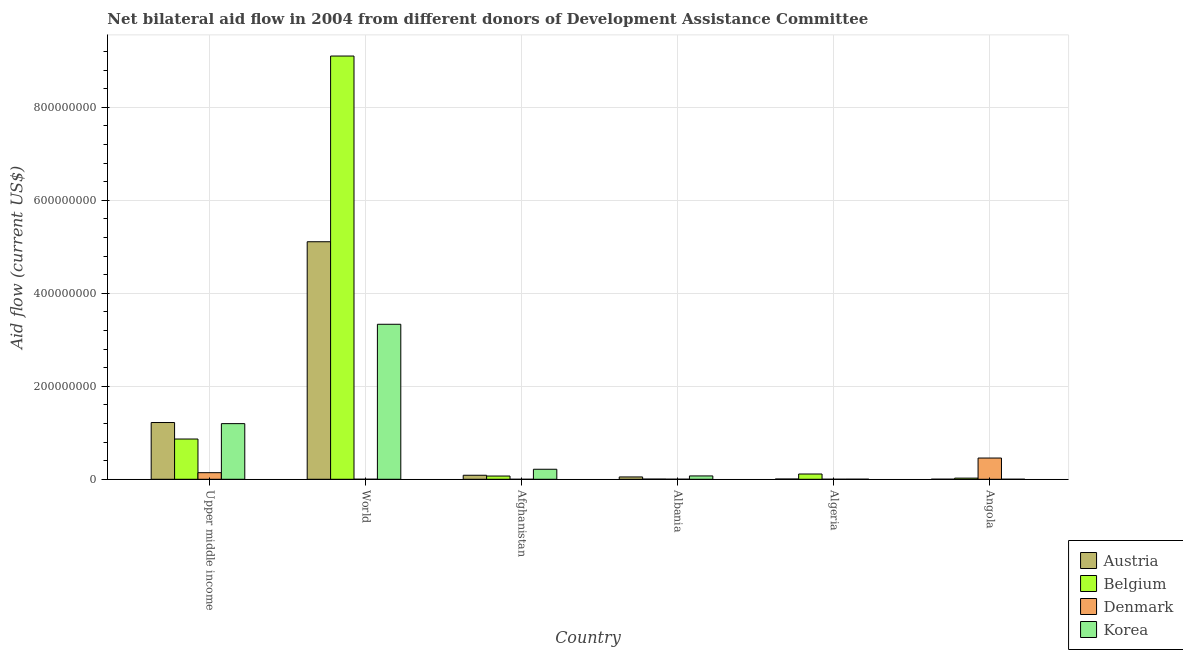Are the number of bars per tick equal to the number of legend labels?
Ensure brevity in your answer.  No. Are the number of bars on each tick of the X-axis equal?
Offer a very short reply. No. How many bars are there on the 5th tick from the left?
Your response must be concise. 4. How many bars are there on the 1st tick from the right?
Your answer should be compact. 4. What is the label of the 1st group of bars from the left?
Provide a short and direct response. Upper middle income. What is the amount of aid given by austria in Afghanistan?
Offer a terse response. 8.65e+06. Across all countries, what is the maximum amount of aid given by belgium?
Your response must be concise. 9.10e+08. Across all countries, what is the minimum amount of aid given by austria?
Ensure brevity in your answer.  1.50e+05. What is the total amount of aid given by korea in the graph?
Make the answer very short. 4.82e+08. What is the difference between the amount of aid given by denmark in Angola and that in World?
Your answer should be very brief. 4.56e+07. What is the difference between the amount of aid given by austria in Angola and the amount of aid given by denmark in Upper middle income?
Offer a terse response. -1.40e+07. What is the average amount of aid given by denmark per country?
Give a very brief answer. 1.00e+07. What is the difference between the amount of aid given by austria and amount of aid given by belgium in Upper middle income?
Your answer should be very brief. 3.55e+07. In how many countries, is the amount of aid given by belgium greater than 640000000 US$?
Provide a succinct answer. 1. What is the ratio of the amount of aid given by belgium in Albania to that in Upper middle income?
Give a very brief answer. 0. What is the difference between the highest and the second highest amount of aid given by denmark?
Your answer should be compact. 3.15e+07. What is the difference between the highest and the lowest amount of aid given by denmark?
Ensure brevity in your answer.  4.57e+07. Is the sum of the amount of aid given by korea in Algeria and Upper middle income greater than the maximum amount of aid given by denmark across all countries?
Provide a short and direct response. Yes. Is it the case that in every country, the sum of the amount of aid given by austria and amount of aid given by belgium is greater than the amount of aid given by denmark?
Your answer should be very brief. No. What is the difference between two consecutive major ticks on the Y-axis?
Offer a terse response. 2.00e+08. Are the values on the major ticks of Y-axis written in scientific E-notation?
Provide a succinct answer. No. Does the graph contain any zero values?
Ensure brevity in your answer.  Yes. How many legend labels are there?
Give a very brief answer. 4. How are the legend labels stacked?
Your answer should be very brief. Vertical. What is the title of the graph?
Make the answer very short. Net bilateral aid flow in 2004 from different donors of Development Assistance Committee. What is the label or title of the X-axis?
Ensure brevity in your answer.  Country. What is the label or title of the Y-axis?
Offer a terse response. Aid flow (current US$). What is the Aid flow (current US$) of Austria in Upper middle income?
Make the answer very short. 1.22e+08. What is the Aid flow (current US$) of Belgium in Upper middle income?
Provide a short and direct response. 8.66e+07. What is the Aid flow (current US$) in Denmark in Upper middle income?
Provide a succinct answer. 1.42e+07. What is the Aid flow (current US$) of Korea in Upper middle income?
Provide a succinct answer. 1.20e+08. What is the Aid flow (current US$) in Austria in World?
Provide a short and direct response. 5.11e+08. What is the Aid flow (current US$) of Belgium in World?
Ensure brevity in your answer.  9.10e+08. What is the Aid flow (current US$) of Denmark in World?
Keep it short and to the point. 3.00e+04. What is the Aid flow (current US$) of Korea in World?
Make the answer very short. 3.33e+08. What is the Aid flow (current US$) in Austria in Afghanistan?
Make the answer very short. 8.65e+06. What is the Aid flow (current US$) in Belgium in Afghanistan?
Make the answer very short. 6.96e+06. What is the Aid flow (current US$) of Denmark in Afghanistan?
Give a very brief answer. 0. What is the Aid flow (current US$) in Korea in Afghanistan?
Your response must be concise. 2.15e+07. What is the Aid flow (current US$) of Austria in Albania?
Make the answer very short. 5.01e+06. What is the Aid flow (current US$) of Denmark in Albania?
Ensure brevity in your answer.  1.20e+05. What is the Aid flow (current US$) of Korea in Albania?
Keep it short and to the point. 7.20e+06. What is the Aid flow (current US$) of Austria in Algeria?
Keep it short and to the point. 5.40e+05. What is the Aid flow (current US$) in Belgium in Algeria?
Offer a terse response. 1.13e+07. What is the Aid flow (current US$) of Denmark in Algeria?
Your answer should be very brief. 6.00e+04. What is the Aid flow (current US$) in Korea in Algeria?
Make the answer very short. 1.40e+05. What is the Aid flow (current US$) of Belgium in Angola?
Give a very brief answer. 2.45e+06. What is the Aid flow (current US$) in Denmark in Angola?
Offer a terse response. 4.57e+07. Across all countries, what is the maximum Aid flow (current US$) in Austria?
Make the answer very short. 5.11e+08. Across all countries, what is the maximum Aid flow (current US$) of Belgium?
Ensure brevity in your answer.  9.10e+08. Across all countries, what is the maximum Aid flow (current US$) in Denmark?
Keep it short and to the point. 4.57e+07. Across all countries, what is the maximum Aid flow (current US$) of Korea?
Give a very brief answer. 3.33e+08. What is the total Aid flow (current US$) in Austria in the graph?
Offer a very short reply. 6.47e+08. What is the total Aid flow (current US$) in Belgium in the graph?
Your answer should be very brief. 1.02e+09. What is the total Aid flow (current US$) of Denmark in the graph?
Make the answer very short. 6.01e+07. What is the total Aid flow (current US$) in Korea in the graph?
Offer a very short reply. 4.82e+08. What is the difference between the Aid flow (current US$) in Austria in Upper middle income and that in World?
Give a very brief answer. -3.89e+08. What is the difference between the Aid flow (current US$) in Belgium in Upper middle income and that in World?
Give a very brief answer. -8.24e+08. What is the difference between the Aid flow (current US$) of Denmark in Upper middle income and that in World?
Keep it short and to the point. 1.42e+07. What is the difference between the Aid flow (current US$) of Korea in Upper middle income and that in World?
Your answer should be very brief. -2.14e+08. What is the difference between the Aid flow (current US$) of Austria in Upper middle income and that in Afghanistan?
Offer a terse response. 1.13e+08. What is the difference between the Aid flow (current US$) of Belgium in Upper middle income and that in Afghanistan?
Provide a succinct answer. 7.96e+07. What is the difference between the Aid flow (current US$) in Korea in Upper middle income and that in Afghanistan?
Your answer should be very brief. 9.81e+07. What is the difference between the Aid flow (current US$) of Austria in Upper middle income and that in Albania?
Offer a very short reply. 1.17e+08. What is the difference between the Aid flow (current US$) in Belgium in Upper middle income and that in Albania?
Provide a short and direct response. 8.62e+07. What is the difference between the Aid flow (current US$) of Denmark in Upper middle income and that in Albania?
Give a very brief answer. 1.41e+07. What is the difference between the Aid flow (current US$) of Korea in Upper middle income and that in Albania?
Your answer should be very brief. 1.12e+08. What is the difference between the Aid flow (current US$) in Austria in Upper middle income and that in Algeria?
Your answer should be compact. 1.22e+08. What is the difference between the Aid flow (current US$) in Belgium in Upper middle income and that in Algeria?
Make the answer very short. 7.53e+07. What is the difference between the Aid flow (current US$) in Denmark in Upper middle income and that in Algeria?
Your answer should be compact. 1.41e+07. What is the difference between the Aid flow (current US$) in Korea in Upper middle income and that in Algeria?
Keep it short and to the point. 1.20e+08. What is the difference between the Aid flow (current US$) in Austria in Upper middle income and that in Angola?
Provide a succinct answer. 1.22e+08. What is the difference between the Aid flow (current US$) of Belgium in Upper middle income and that in Angola?
Offer a terse response. 8.41e+07. What is the difference between the Aid flow (current US$) in Denmark in Upper middle income and that in Angola?
Offer a very short reply. -3.15e+07. What is the difference between the Aid flow (current US$) of Korea in Upper middle income and that in Angola?
Keep it short and to the point. 1.20e+08. What is the difference between the Aid flow (current US$) in Austria in World and that in Afghanistan?
Make the answer very short. 5.02e+08. What is the difference between the Aid flow (current US$) of Belgium in World and that in Afghanistan?
Ensure brevity in your answer.  9.03e+08. What is the difference between the Aid flow (current US$) of Korea in World and that in Afghanistan?
Keep it short and to the point. 3.12e+08. What is the difference between the Aid flow (current US$) of Austria in World and that in Albania?
Give a very brief answer. 5.06e+08. What is the difference between the Aid flow (current US$) in Belgium in World and that in Albania?
Offer a terse response. 9.10e+08. What is the difference between the Aid flow (current US$) in Korea in World and that in Albania?
Ensure brevity in your answer.  3.26e+08. What is the difference between the Aid flow (current US$) in Austria in World and that in Algeria?
Make the answer very short. 5.10e+08. What is the difference between the Aid flow (current US$) of Belgium in World and that in Algeria?
Provide a succinct answer. 8.99e+08. What is the difference between the Aid flow (current US$) in Denmark in World and that in Algeria?
Offer a very short reply. -3.00e+04. What is the difference between the Aid flow (current US$) in Korea in World and that in Algeria?
Your response must be concise. 3.33e+08. What is the difference between the Aid flow (current US$) of Austria in World and that in Angola?
Make the answer very short. 5.11e+08. What is the difference between the Aid flow (current US$) in Belgium in World and that in Angola?
Give a very brief answer. 9.08e+08. What is the difference between the Aid flow (current US$) in Denmark in World and that in Angola?
Make the answer very short. -4.56e+07. What is the difference between the Aid flow (current US$) in Korea in World and that in Angola?
Your answer should be compact. 3.33e+08. What is the difference between the Aid flow (current US$) of Austria in Afghanistan and that in Albania?
Offer a very short reply. 3.64e+06. What is the difference between the Aid flow (current US$) in Belgium in Afghanistan and that in Albania?
Ensure brevity in your answer.  6.59e+06. What is the difference between the Aid flow (current US$) in Korea in Afghanistan and that in Albania?
Your answer should be compact. 1.43e+07. What is the difference between the Aid flow (current US$) of Austria in Afghanistan and that in Algeria?
Ensure brevity in your answer.  8.11e+06. What is the difference between the Aid flow (current US$) of Belgium in Afghanistan and that in Algeria?
Provide a short and direct response. -4.36e+06. What is the difference between the Aid flow (current US$) of Korea in Afghanistan and that in Algeria?
Your answer should be compact. 2.14e+07. What is the difference between the Aid flow (current US$) in Austria in Afghanistan and that in Angola?
Make the answer very short. 8.50e+06. What is the difference between the Aid flow (current US$) of Belgium in Afghanistan and that in Angola?
Your answer should be compact. 4.51e+06. What is the difference between the Aid flow (current US$) of Korea in Afghanistan and that in Angola?
Provide a succinct answer. 2.15e+07. What is the difference between the Aid flow (current US$) of Austria in Albania and that in Algeria?
Make the answer very short. 4.47e+06. What is the difference between the Aid flow (current US$) of Belgium in Albania and that in Algeria?
Provide a succinct answer. -1.10e+07. What is the difference between the Aid flow (current US$) of Korea in Albania and that in Algeria?
Provide a short and direct response. 7.06e+06. What is the difference between the Aid flow (current US$) of Austria in Albania and that in Angola?
Give a very brief answer. 4.86e+06. What is the difference between the Aid flow (current US$) of Belgium in Albania and that in Angola?
Offer a terse response. -2.08e+06. What is the difference between the Aid flow (current US$) in Denmark in Albania and that in Angola?
Your response must be concise. -4.56e+07. What is the difference between the Aid flow (current US$) in Korea in Albania and that in Angola?
Provide a short and direct response. 7.16e+06. What is the difference between the Aid flow (current US$) of Belgium in Algeria and that in Angola?
Offer a terse response. 8.87e+06. What is the difference between the Aid flow (current US$) of Denmark in Algeria and that in Angola?
Make the answer very short. -4.56e+07. What is the difference between the Aid flow (current US$) of Korea in Algeria and that in Angola?
Give a very brief answer. 1.00e+05. What is the difference between the Aid flow (current US$) of Austria in Upper middle income and the Aid flow (current US$) of Belgium in World?
Provide a succinct answer. -7.88e+08. What is the difference between the Aid flow (current US$) in Austria in Upper middle income and the Aid flow (current US$) in Denmark in World?
Offer a terse response. 1.22e+08. What is the difference between the Aid flow (current US$) in Austria in Upper middle income and the Aid flow (current US$) in Korea in World?
Provide a short and direct response. -2.11e+08. What is the difference between the Aid flow (current US$) of Belgium in Upper middle income and the Aid flow (current US$) of Denmark in World?
Offer a very short reply. 8.66e+07. What is the difference between the Aid flow (current US$) in Belgium in Upper middle income and the Aid flow (current US$) in Korea in World?
Offer a very short reply. -2.47e+08. What is the difference between the Aid flow (current US$) in Denmark in Upper middle income and the Aid flow (current US$) in Korea in World?
Offer a very short reply. -3.19e+08. What is the difference between the Aid flow (current US$) of Austria in Upper middle income and the Aid flow (current US$) of Belgium in Afghanistan?
Your response must be concise. 1.15e+08. What is the difference between the Aid flow (current US$) of Austria in Upper middle income and the Aid flow (current US$) of Korea in Afghanistan?
Ensure brevity in your answer.  1.01e+08. What is the difference between the Aid flow (current US$) of Belgium in Upper middle income and the Aid flow (current US$) of Korea in Afghanistan?
Make the answer very short. 6.50e+07. What is the difference between the Aid flow (current US$) in Denmark in Upper middle income and the Aid flow (current US$) in Korea in Afghanistan?
Give a very brief answer. -7.36e+06. What is the difference between the Aid flow (current US$) of Austria in Upper middle income and the Aid flow (current US$) of Belgium in Albania?
Your response must be concise. 1.22e+08. What is the difference between the Aid flow (current US$) in Austria in Upper middle income and the Aid flow (current US$) in Denmark in Albania?
Offer a very short reply. 1.22e+08. What is the difference between the Aid flow (current US$) in Austria in Upper middle income and the Aid flow (current US$) in Korea in Albania?
Provide a short and direct response. 1.15e+08. What is the difference between the Aid flow (current US$) in Belgium in Upper middle income and the Aid flow (current US$) in Denmark in Albania?
Your answer should be very brief. 8.65e+07. What is the difference between the Aid flow (current US$) of Belgium in Upper middle income and the Aid flow (current US$) of Korea in Albania?
Your response must be concise. 7.94e+07. What is the difference between the Aid flow (current US$) of Denmark in Upper middle income and the Aid flow (current US$) of Korea in Albania?
Provide a short and direct response. 6.98e+06. What is the difference between the Aid flow (current US$) in Austria in Upper middle income and the Aid flow (current US$) in Belgium in Algeria?
Provide a short and direct response. 1.11e+08. What is the difference between the Aid flow (current US$) of Austria in Upper middle income and the Aid flow (current US$) of Denmark in Algeria?
Offer a terse response. 1.22e+08. What is the difference between the Aid flow (current US$) of Austria in Upper middle income and the Aid flow (current US$) of Korea in Algeria?
Provide a short and direct response. 1.22e+08. What is the difference between the Aid flow (current US$) in Belgium in Upper middle income and the Aid flow (current US$) in Denmark in Algeria?
Make the answer very short. 8.65e+07. What is the difference between the Aid flow (current US$) in Belgium in Upper middle income and the Aid flow (current US$) in Korea in Algeria?
Keep it short and to the point. 8.64e+07. What is the difference between the Aid flow (current US$) in Denmark in Upper middle income and the Aid flow (current US$) in Korea in Algeria?
Your answer should be compact. 1.40e+07. What is the difference between the Aid flow (current US$) of Austria in Upper middle income and the Aid flow (current US$) of Belgium in Angola?
Provide a short and direct response. 1.20e+08. What is the difference between the Aid flow (current US$) in Austria in Upper middle income and the Aid flow (current US$) in Denmark in Angola?
Provide a succinct answer. 7.64e+07. What is the difference between the Aid flow (current US$) of Austria in Upper middle income and the Aid flow (current US$) of Korea in Angola?
Provide a succinct answer. 1.22e+08. What is the difference between the Aid flow (current US$) of Belgium in Upper middle income and the Aid flow (current US$) of Denmark in Angola?
Make the answer very short. 4.09e+07. What is the difference between the Aid flow (current US$) in Belgium in Upper middle income and the Aid flow (current US$) in Korea in Angola?
Keep it short and to the point. 8.65e+07. What is the difference between the Aid flow (current US$) in Denmark in Upper middle income and the Aid flow (current US$) in Korea in Angola?
Your answer should be compact. 1.41e+07. What is the difference between the Aid flow (current US$) in Austria in World and the Aid flow (current US$) in Belgium in Afghanistan?
Ensure brevity in your answer.  5.04e+08. What is the difference between the Aid flow (current US$) of Austria in World and the Aid flow (current US$) of Korea in Afghanistan?
Your response must be concise. 4.89e+08. What is the difference between the Aid flow (current US$) in Belgium in World and the Aid flow (current US$) in Korea in Afghanistan?
Ensure brevity in your answer.  8.89e+08. What is the difference between the Aid flow (current US$) in Denmark in World and the Aid flow (current US$) in Korea in Afghanistan?
Your answer should be compact. -2.15e+07. What is the difference between the Aid flow (current US$) in Austria in World and the Aid flow (current US$) in Belgium in Albania?
Ensure brevity in your answer.  5.10e+08. What is the difference between the Aid flow (current US$) in Austria in World and the Aid flow (current US$) in Denmark in Albania?
Make the answer very short. 5.11e+08. What is the difference between the Aid flow (current US$) of Austria in World and the Aid flow (current US$) of Korea in Albania?
Provide a short and direct response. 5.04e+08. What is the difference between the Aid flow (current US$) in Belgium in World and the Aid flow (current US$) in Denmark in Albania?
Your answer should be compact. 9.10e+08. What is the difference between the Aid flow (current US$) of Belgium in World and the Aid flow (current US$) of Korea in Albania?
Offer a terse response. 9.03e+08. What is the difference between the Aid flow (current US$) in Denmark in World and the Aid flow (current US$) in Korea in Albania?
Provide a short and direct response. -7.17e+06. What is the difference between the Aid flow (current US$) in Austria in World and the Aid flow (current US$) in Belgium in Algeria?
Give a very brief answer. 5.00e+08. What is the difference between the Aid flow (current US$) in Austria in World and the Aid flow (current US$) in Denmark in Algeria?
Keep it short and to the point. 5.11e+08. What is the difference between the Aid flow (current US$) of Austria in World and the Aid flow (current US$) of Korea in Algeria?
Ensure brevity in your answer.  5.11e+08. What is the difference between the Aid flow (current US$) of Belgium in World and the Aid flow (current US$) of Denmark in Algeria?
Provide a succinct answer. 9.10e+08. What is the difference between the Aid flow (current US$) of Belgium in World and the Aid flow (current US$) of Korea in Algeria?
Make the answer very short. 9.10e+08. What is the difference between the Aid flow (current US$) in Denmark in World and the Aid flow (current US$) in Korea in Algeria?
Keep it short and to the point. -1.10e+05. What is the difference between the Aid flow (current US$) of Austria in World and the Aid flow (current US$) of Belgium in Angola?
Provide a short and direct response. 5.08e+08. What is the difference between the Aid flow (current US$) of Austria in World and the Aid flow (current US$) of Denmark in Angola?
Offer a terse response. 4.65e+08. What is the difference between the Aid flow (current US$) in Austria in World and the Aid flow (current US$) in Korea in Angola?
Give a very brief answer. 5.11e+08. What is the difference between the Aid flow (current US$) in Belgium in World and the Aid flow (current US$) in Denmark in Angola?
Keep it short and to the point. 8.65e+08. What is the difference between the Aid flow (current US$) in Belgium in World and the Aid flow (current US$) in Korea in Angola?
Offer a terse response. 9.10e+08. What is the difference between the Aid flow (current US$) of Austria in Afghanistan and the Aid flow (current US$) of Belgium in Albania?
Your answer should be compact. 8.28e+06. What is the difference between the Aid flow (current US$) in Austria in Afghanistan and the Aid flow (current US$) in Denmark in Albania?
Your answer should be compact. 8.53e+06. What is the difference between the Aid flow (current US$) in Austria in Afghanistan and the Aid flow (current US$) in Korea in Albania?
Your answer should be compact. 1.45e+06. What is the difference between the Aid flow (current US$) of Belgium in Afghanistan and the Aid flow (current US$) of Denmark in Albania?
Make the answer very short. 6.84e+06. What is the difference between the Aid flow (current US$) in Belgium in Afghanistan and the Aid flow (current US$) in Korea in Albania?
Offer a terse response. -2.40e+05. What is the difference between the Aid flow (current US$) of Austria in Afghanistan and the Aid flow (current US$) of Belgium in Algeria?
Your answer should be very brief. -2.67e+06. What is the difference between the Aid flow (current US$) in Austria in Afghanistan and the Aid flow (current US$) in Denmark in Algeria?
Provide a short and direct response. 8.59e+06. What is the difference between the Aid flow (current US$) in Austria in Afghanistan and the Aid flow (current US$) in Korea in Algeria?
Make the answer very short. 8.51e+06. What is the difference between the Aid flow (current US$) of Belgium in Afghanistan and the Aid flow (current US$) of Denmark in Algeria?
Offer a terse response. 6.90e+06. What is the difference between the Aid flow (current US$) of Belgium in Afghanistan and the Aid flow (current US$) of Korea in Algeria?
Give a very brief answer. 6.82e+06. What is the difference between the Aid flow (current US$) in Austria in Afghanistan and the Aid flow (current US$) in Belgium in Angola?
Ensure brevity in your answer.  6.20e+06. What is the difference between the Aid flow (current US$) of Austria in Afghanistan and the Aid flow (current US$) of Denmark in Angola?
Keep it short and to the point. -3.70e+07. What is the difference between the Aid flow (current US$) in Austria in Afghanistan and the Aid flow (current US$) in Korea in Angola?
Provide a succinct answer. 8.61e+06. What is the difference between the Aid flow (current US$) of Belgium in Afghanistan and the Aid flow (current US$) of Denmark in Angola?
Provide a short and direct response. -3.87e+07. What is the difference between the Aid flow (current US$) in Belgium in Afghanistan and the Aid flow (current US$) in Korea in Angola?
Ensure brevity in your answer.  6.92e+06. What is the difference between the Aid flow (current US$) of Austria in Albania and the Aid flow (current US$) of Belgium in Algeria?
Give a very brief answer. -6.31e+06. What is the difference between the Aid flow (current US$) of Austria in Albania and the Aid flow (current US$) of Denmark in Algeria?
Give a very brief answer. 4.95e+06. What is the difference between the Aid flow (current US$) of Austria in Albania and the Aid flow (current US$) of Korea in Algeria?
Give a very brief answer. 4.87e+06. What is the difference between the Aid flow (current US$) of Belgium in Albania and the Aid flow (current US$) of Denmark in Algeria?
Provide a short and direct response. 3.10e+05. What is the difference between the Aid flow (current US$) of Belgium in Albania and the Aid flow (current US$) of Korea in Algeria?
Make the answer very short. 2.30e+05. What is the difference between the Aid flow (current US$) in Austria in Albania and the Aid flow (current US$) in Belgium in Angola?
Give a very brief answer. 2.56e+06. What is the difference between the Aid flow (current US$) of Austria in Albania and the Aid flow (current US$) of Denmark in Angola?
Provide a succinct answer. -4.07e+07. What is the difference between the Aid flow (current US$) in Austria in Albania and the Aid flow (current US$) in Korea in Angola?
Provide a short and direct response. 4.97e+06. What is the difference between the Aid flow (current US$) of Belgium in Albania and the Aid flow (current US$) of Denmark in Angola?
Provide a short and direct response. -4.53e+07. What is the difference between the Aid flow (current US$) in Austria in Algeria and the Aid flow (current US$) in Belgium in Angola?
Give a very brief answer. -1.91e+06. What is the difference between the Aid flow (current US$) of Austria in Algeria and the Aid flow (current US$) of Denmark in Angola?
Provide a short and direct response. -4.51e+07. What is the difference between the Aid flow (current US$) of Austria in Algeria and the Aid flow (current US$) of Korea in Angola?
Your answer should be compact. 5.00e+05. What is the difference between the Aid flow (current US$) in Belgium in Algeria and the Aid flow (current US$) in Denmark in Angola?
Keep it short and to the point. -3.44e+07. What is the difference between the Aid flow (current US$) in Belgium in Algeria and the Aid flow (current US$) in Korea in Angola?
Offer a very short reply. 1.13e+07. What is the difference between the Aid flow (current US$) of Denmark in Algeria and the Aid flow (current US$) of Korea in Angola?
Your response must be concise. 2.00e+04. What is the average Aid flow (current US$) in Austria per country?
Your response must be concise. 1.08e+08. What is the average Aid flow (current US$) of Belgium per country?
Your answer should be very brief. 1.70e+08. What is the average Aid flow (current US$) in Denmark per country?
Ensure brevity in your answer.  1.00e+07. What is the average Aid flow (current US$) of Korea per country?
Provide a succinct answer. 8.03e+07. What is the difference between the Aid flow (current US$) in Austria and Aid flow (current US$) in Belgium in Upper middle income?
Provide a short and direct response. 3.55e+07. What is the difference between the Aid flow (current US$) of Austria and Aid flow (current US$) of Denmark in Upper middle income?
Your answer should be compact. 1.08e+08. What is the difference between the Aid flow (current US$) of Austria and Aid flow (current US$) of Korea in Upper middle income?
Your answer should be compact. 2.39e+06. What is the difference between the Aid flow (current US$) in Belgium and Aid flow (current US$) in Denmark in Upper middle income?
Offer a terse response. 7.24e+07. What is the difference between the Aid flow (current US$) of Belgium and Aid flow (current US$) of Korea in Upper middle income?
Offer a very short reply. -3.31e+07. What is the difference between the Aid flow (current US$) in Denmark and Aid flow (current US$) in Korea in Upper middle income?
Make the answer very short. -1.06e+08. What is the difference between the Aid flow (current US$) of Austria and Aid flow (current US$) of Belgium in World?
Ensure brevity in your answer.  -3.99e+08. What is the difference between the Aid flow (current US$) in Austria and Aid flow (current US$) in Denmark in World?
Your answer should be compact. 5.11e+08. What is the difference between the Aid flow (current US$) in Austria and Aid flow (current US$) in Korea in World?
Keep it short and to the point. 1.78e+08. What is the difference between the Aid flow (current US$) in Belgium and Aid flow (current US$) in Denmark in World?
Give a very brief answer. 9.10e+08. What is the difference between the Aid flow (current US$) of Belgium and Aid flow (current US$) of Korea in World?
Your answer should be very brief. 5.77e+08. What is the difference between the Aid flow (current US$) in Denmark and Aid flow (current US$) in Korea in World?
Provide a short and direct response. -3.33e+08. What is the difference between the Aid flow (current US$) in Austria and Aid flow (current US$) in Belgium in Afghanistan?
Keep it short and to the point. 1.69e+06. What is the difference between the Aid flow (current US$) in Austria and Aid flow (current US$) in Korea in Afghanistan?
Give a very brief answer. -1.29e+07. What is the difference between the Aid flow (current US$) in Belgium and Aid flow (current US$) in Korea in Afghanistan?
Make the answer very short. -1.46e+07. What is the difference between the Aid flow (current US$) in Austria and Aid flow (current US$) in Belgium in Albania?
Offer a terse response. 4.64e+06. What is the difference between the Aid flow (current US$) in Austria and Aid flow (current US$) in Denmark in Albania?
Ensure brevity in your answer.  4.89e+06. What is the difference between the Aid flow (current US$) in Austria and Aid flow (current US$) in Korea in Albania?
Offer a very short reply. -2.19e+06. What is the difference between the Aid flow (current US$) of Belgium and Aid flow (current US$) of Denmark in Albania?
Ensure brevity in your answer.  2.50e+05. What is the difference between the Aid flow (current US$) of Belgium and Aid flow (current US$) of Korea in Albania?
Ensure brevity in your answer.  -6.83e+06. What is the difference between the Aid flow (current US$) of Denmark and Aid flow (current US$) of Korea in Albania?
Keep it short and to the point. -7.08e+06. What is the difference between the Aid flow (current US$) of Austria and Aid flow (current US$) of Belgium in Algeria?
Your answer should be very brief. -1.08e+07. What is the difference between the Aid flow (current US$) in Austria and Aid flow (current US$) in Korea in Algeria?
Provide a succinct answer. 4.00e+05. What is the difference between the Aid flow (current US$) of Belgium and Aid flow (current US$) of Denmark in Algeria?
Offer a terse response. 1.13e+07. What is the difference between the Aid flow (current US$) of Belgium and Aid flow (current US$) of Korea in Algeria?
Make the answer very short. 1.12e+07. What is the difference between the Aid flow (current US$) in Denmark and Aid flow (current US$) in Korea in Algeria?
Make the answer very short. -8.00e+04. What is the difference between the Aid flow (current US$) of Austria and Aid flow (current US$) of Belgium in Angola?
Provide a short and direct response. -2.30e+06. What is the difference between the Aid flow (current US$) of Austria and Aid flow (current US$) of Denmark in Angola?
Provide a succinct answer. -4.55e+07. What is the difference between the Aid flow (current US$) in Austria and Aid flow (current US$) in Korea in Angola?
Offer a very short reply. 1.10e+05. What is the difference between the Aid flow (current US$) in Belgium and Aid flow (current US$) in Denmark in Angola?
Give a very brief answer. -4.32e+07. What is the difference between the Aid flow (current US$) in Belgium and Aid flow (current US$) in Korea in Angola?
Your response must be concise. 2.41e+06. What is the difference between the Aid flow (current US$) in Denmark and Aid flow (current US$) in Korea in Angola?
Your answer should be compact. 4.56e+07. What is the ratio of the Aid flow (current US$) in Austria in Upper middle income to that in World?
Make the answer very short. 0.24. What is the ratio of the Aid flow (current US$) of Belgium in Upper middle income to that in World?
Make the answer very short. 0.1. What is the ratio of the Aid flow (current US$) of Denmark in Upper middle income to that in World?
Make the answer very short. 472.67. What is the ratio of the Aid flow (current US$) in Korea in Upper middle income to that in World?
Keep it short and to the point. 0.36. What is the ratio of the Aid flow (current US$) in Austria in Upper middle income to that in Afghanistan?
Give a very brief answer. 14.11. What is the ratio of the Aid flow (current US$) of Belgium in Upper middle income to that in Afghanistan?
Your answer should be very brief. 12.44. What is the ratio of the Aid flow (current US$) in Korea in Upper middle income to that in Afghanistan?
Ensure brevity in your answer.  5.56. What is the ratio of the Aid flow (current US$) of Austria in Upper middle income to that in Albania?
Provide a succinct answer. 24.37. What is the ratio of the Aid flow (current US$) in Belgium in Upper middle income to that in Albania?
Make the answer very short. 234. What is the ratio of the Aid flow (current US$) in Denmark in Upper middle income to that in Albania?
Your answer should be very brief. 118.17. What is the ratio of the Aid flow (current US$) of Korea in Upper middle income to that in Albania?
Your answer should be very brief. 16.62. What is the ratio of the Aid flow (current US$) in Austria in Upper middle income to that in Algeria?
Your response must be concise. 226.06. What is the ratio of the Aid flow (current US$) of Belgium in Upper middle income to that in Algeria?
Give a very brief answer. 7.65. What is the ratio of the Aid flow (current US$) of Denmark in Upper middle income to that in Algeria?
Offer a terse response. 236.33. What is the ratio of the Aid flow (current US$) of Korea in Upper middle income to that in Algeria?
Ensure brevity in your answer.  854.86. What is the ratio of the Aid flow (current US$) in Austria in Upper middle income to that in Angola?
Give a very brief answer. 813.8. What is the ratio of the Aid flow (current US$) of Belgium in Upper middle income to that in Angola?
Give a very brief answer. 35.34. What is the ratio of the Aid flow (current US$) in Denmark in Upper middle income to that in Angola?
Your response must be concise. 0.31. What is the ratio of the Aid flow (current US$) in Korea in Upper middle income to that in Angola?
Your answer should be very brief. 2992. What is the ratio of the Aid flow (current US$) of Austria in World to that in Afghanistan?
Offer a very short reply. 59.06. What is the ratio of the Aid flow (current US$) in Belgium in World to that in Afghanistan?
Ensure brevity in your answer.  130.79. What is the ratio of the Aid flow (current US$) of Korea in World to that in Afghanistan?
Provide a succinct answer. 15.48. What is the ratio of the Aid flow (current US$) in Austria in World to that in Albania?
Your answer should be compact. 101.97. What is the ratio of the Aid flow (current US$) of Belgium in World to that in Albania?
Offer a terse response. 2460.27. What is the ratio of the Aid flow (current US$) of Korea in World to that in Albania?
Your answer should be compact. 46.3. What is the ratio of the Aid flow (current US$) of Austria in World to that in Algeria?
Your answer should be very brief. 946.06. What is the ratio of the Aid flow (current US$) of Belgium in World to that in Algeria?
Offer a terse response. 80.42. What is the ratio of the Aid flow (current US$) in Denmark in World to that in Algeria?
Your response must be concise. 0.5. What is the ratio of the Aid flow (current US$) in Korea in World to that in Algeria?
Provide a short and direct response. 2381.21. What is the ratio of the Aid flow (current US$) of Austria in World to that in Angola?
Offer a very short reply. 3405.8. What is the ratio of the Aid flow (current US$) of Belgium in World to that in Angola?
Offer a very short reply. 371.55. What is the ratio of the Aid flow (current US$) in Denmark in World to that in Angola?
Ensure brevity in your answer.  0. What is the ratio of the Aid flow (current US$) in Korea in World to that in Angola?
Offer a very short reply. 8334.25. What is the ratio of the Aid flow (current US$) in Austria in Afghanistan to that in Albania?
Provide a succinct answer. 1.73. What is the ratio of the Aid flow (current US$) of Belgium in Afghanistan to that in Albania?
Your answer should be very brief. 18.81. What is the ratio of the Aid flow (current US$) in Korea in Afghanistan to that in Albania?
Your answer should be compact. 2.99. What is the ratio of the Aid flow (current US$) in Austria in Afghanistan to that in Algeria?
Give a very brief answer. 16.02. What is the ratio of the Aid flow (current US$) of Belgium in Afghanistan to that in Algeria?
Offer a terse response. 0.61. What is the ratio of the Aid flow (current US$) in Korea in Afghanistan to that in Algeria?
Provide a short and direct response. 153.86. What is the ratio of the Aid flow (current US$) in Austria in Afghanistan to that in Angola?
Provide a short and direct response. 57.67. What is the ratio of the Aid flow (current US$) in Belgium in Afghanistan to that in Angola?
Give a very brief answer. 2.84. What is the ratio of the Aid flow (current US$) of Korea in Afghanistan to that in Angola?
Offer a terse response. 538.5. What is the ratio of the Aid flow (current US$) in Austria in Albania to that in Algeria?
Your response must be concise. 9.28. What is the ratio of the Aid flow (current US$) in Belgium in Albania to that in Algeria?
Make the answer very short. 0.03. What is the ratio of the Aid flow (current US$) in Korea in Albania to that in Algeria?
Give a very brief answer. 51.43. What is the ratio of the Aid flow (current US$) in Austria in Albania to that in Angola?
Provide a succinct answer. 33.4. What is the ratio of the Aid flow (current US$) in Belgium in Albania to that in Angola?
Your response must be concise. 0.15. What is the ratio of the Aid flow (current US$) in Denmark in Albania to that in Angola?
Provide a short and direct response. 0. What is the ratio of the Aid flow (current US$) of Korea in Albania to that in Angola?
Provide a short and direct response. 180. What is the ratio of the Aid flow (current US$) in Austria in Algeria to that in Angola?
Make the answer very short. 3.6. What is the ratio of the Aid flow (current US$) of Belgium in Algeria to that in Angola?
Provide a short and direct response. 4.62. What is the ratio of the Aid flow (current US$) of Denmark in Algeria to that in Angola?
Your response must be concise. 0. What is the difference between the highest and the second highest Aid flow (current US$) of Austria?
Ensure brevity in your answer.  3.89e+08. What is the difference between the highest and the second highest Aid flow (current US$) of Belgium?
Your response must be concise. 8.24e+08. What is the difference between the highest and the second highest Aid flow (current US$) in Denmark?
Offer a very short reply. 3.15e+07. What is the difference between the highest and the second highest Aid flow (current US$) of Korea?
Offer a terse response. 2.14e+08. What is the difference between the highest and the lowest Aid flow (current US$) in Austria?
Offer a terse response. 5.11e+08. What is the difference between the highest and the lowest Aid flow (current US$) of Belgium?
Your response must be concise. 9.10e+08. What is the difference between the highest and the lowest Aid flow (current US$) of Denmark?
Ensure brevity in your answer.  4.57e+07. What is the difference between the highest and the lowest Aid flow (current US$) in Korea?
Your answer should be very brief. 3.33e+08. 